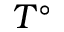<formula> <loc_0><loc_0><loc_500><loc_500>T ^ { \circ }</formula> 